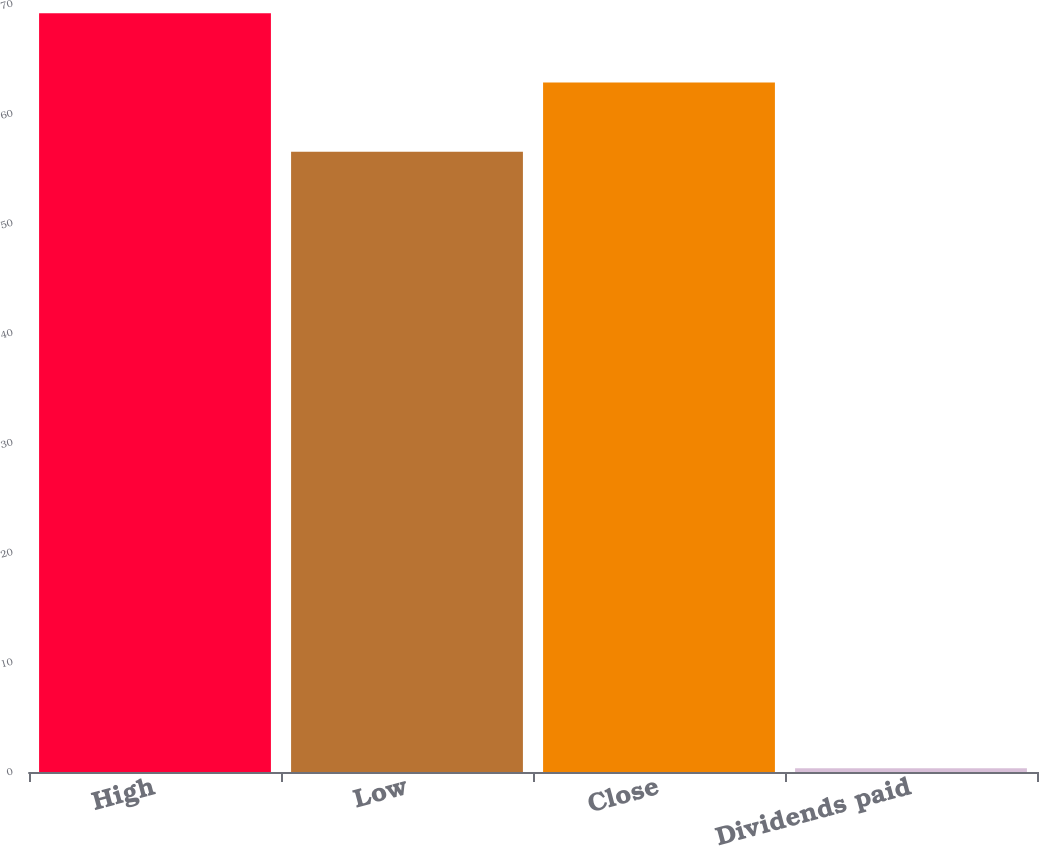Convert chart. <chart><loc_0><loc_0><loc_500><loc_500><bar_chart><fcel>High<fcel>Low<fcel>Close<fcel>Dividends paid<nl><fcel>69.15<fcel>56.53<fcel>62.84<fcel>0.34<nl></chart> 